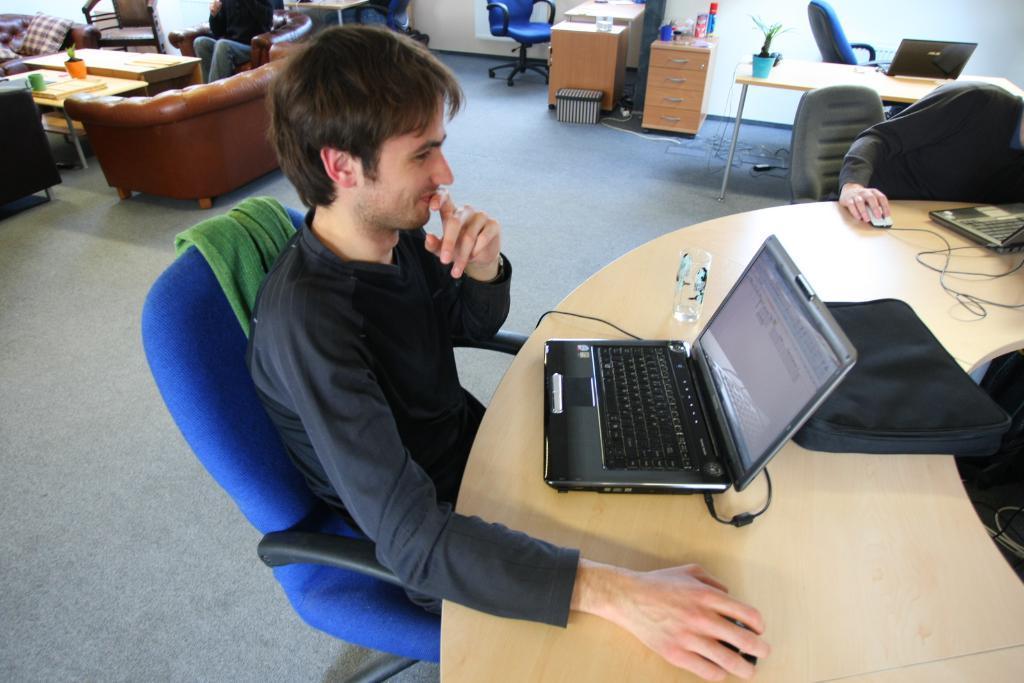Please provide a concise description of this image. There are two people sitting on the chairs. This is a table with laptops,mouses,glass and laptop bag placed on the table. This is a desk with drawers. There are few objects placed on the desk. I can see another table with flower pot and laptop placed on it. There are two empty chairs. I can see another person sitting on the couch. This is a couch which is brown in color. I can see a teapot with flower pot,cup placed on it. This is the floor. 